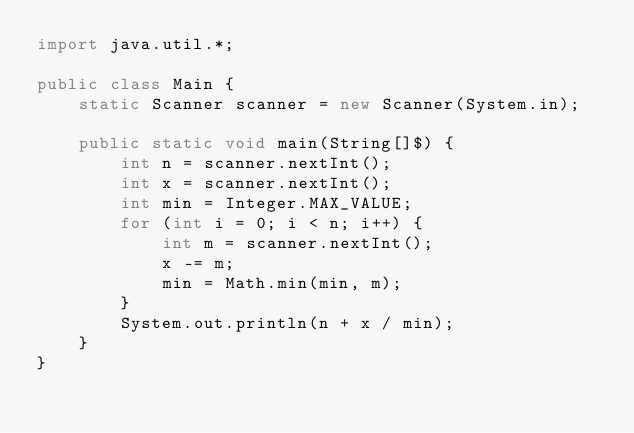<code> <loc_0><loc_0><loc_500><loc_500><_Java_>import java.util.*;

public class Main {
    static Scanner scanner = new Scanner(System.in);

    public static void main(String[]$) {
        int n = scanner.nextInt();
        int x = scanner.nextInt();
        int min = Integer.MAX_VALUE;
        for (int i = 0; i < n; i++) {
            int m = scanner.nextInt();
            x -= m;
            min = Math.min(min, m);
        }
        System.out.println(n + x / min);
    }
}</code> 